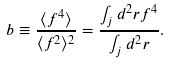<formula> <loc_0><loc_0><loc_500><loc_500>b \equiv \frac { \langle f ^ { 4 } \rangle } { \langle f ^ { 2 } \rangle ^ { 2 } } = \frac { \int _ { j } d ^ { 2 } r f ^ { 4 } } { \int _ { j } d ^ { 2 } r } .</formula> 